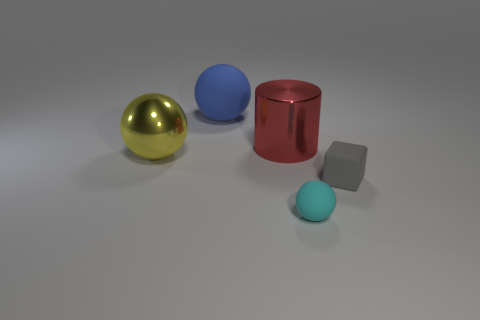Subtract all large matte balls. How many balls are left? 2 Add 3 small gray things. How many objects exist? 8 Subtract all yellow spheres. How many spheres are left? 2 Subtract all spheres. How many objects are left? 2 Subtract 2 balls. How many balls are left? 1 Subtract all gray cylinders. Subtract all brown spheres. How many cylinders are left? 1 Subtract all large purple metal spheres. Subtract all small gray cubes. How many objects are left? 4 Add 3 small matte cubes. How many small matte cubes are left? 4 Add 4 gray balls. How many gray balls exist? 4 Subtract 1 red cylinders. How many objects are left? 4 